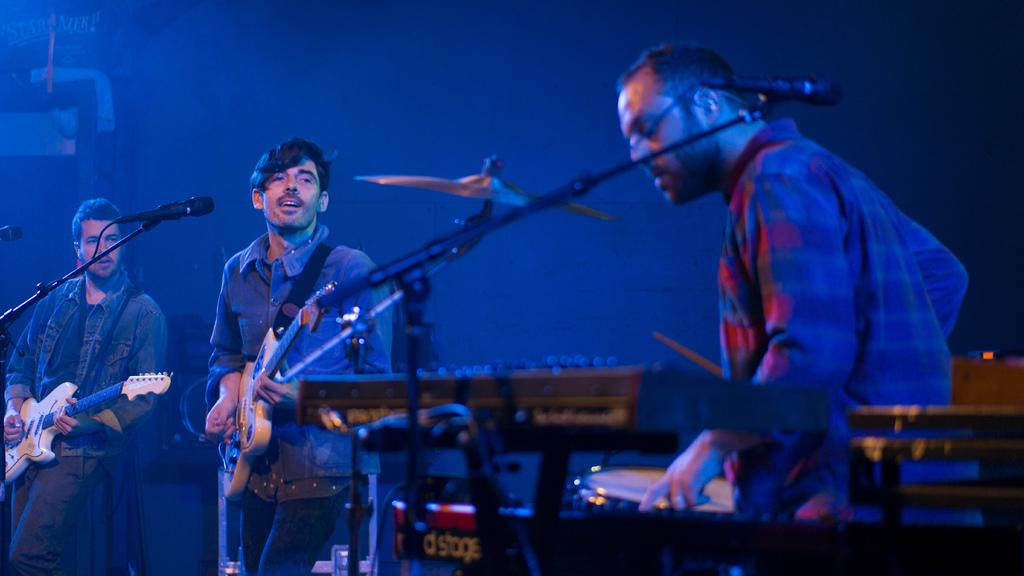How many people are in the image? There are three persons in the image. What are two of the persons holding? Two of the persons are holding guitars. What is one person doing in the image? One person is playing a musical instrument. What equipment is present in front of one person? There is a microphone and holder in front of one person. What type of bushes can be seen growing around the musical instruments in the image? There are no bushes present in the image; it features three persons with guitars and a microphone. What type of attraction is the image promoting? The image does not appear to be promoting any specific attraction; it simply shows three people with musical instruments. 